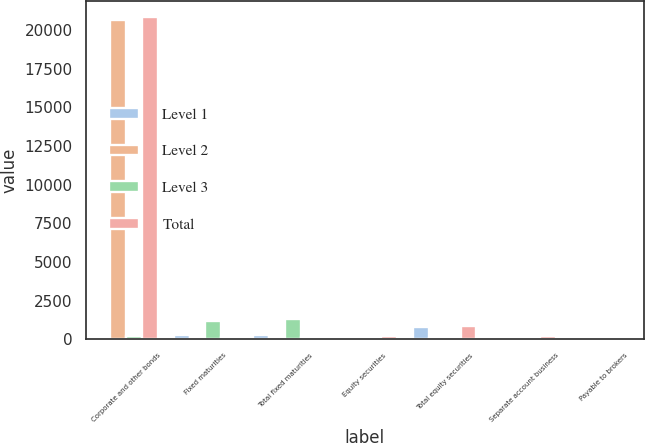<chart> <loc_0><loc_0><loc_500><loc_500><stacked_bar_chart><ecel><fcel>Corporate and other bonds<fcel>Fixed maturities<fcel>Total fixed maturities<fcel>Equity securities<fcel>Total equity securities<fcel>Separate account business<fcel>Payable to brokers<nl><fcel>Level 1<fcel>33<fcel>275<fcel>275<fcel>126<fcel>804<fcel>9<fcel>40<nl><fcel>Level 2<fcel>20625<fcel>148.5<fcel>148.5<fcel>48<fcel>48<fcel>171<fcel>7<nl><fcel>Level 3<fcel>204<fcel>1203<fcel>1283<fcel>11<fcel>19<fcel>1<fcel>5<nl><fcel>Total<fcel>20862<fcel>148.5<fcel>148.5<fcel>185<fcel>871<fcel>181<fcel>52<nl></chart> 